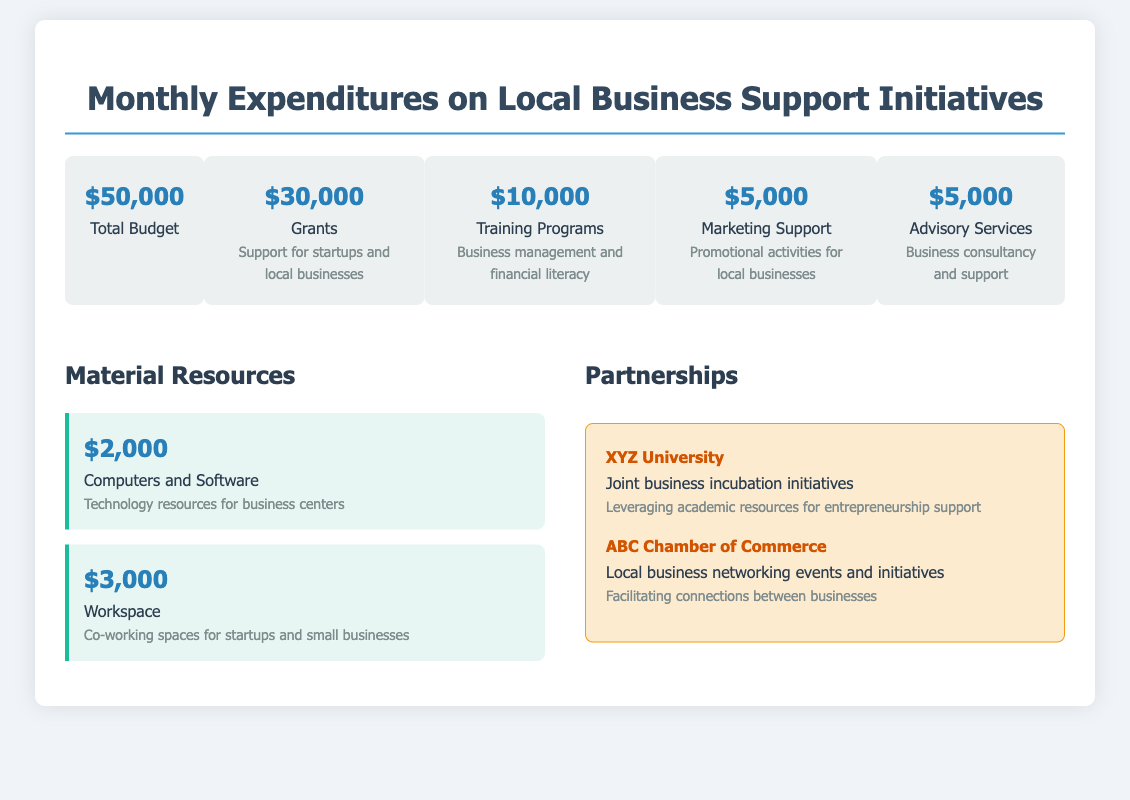What is the total budget? The total budget is displayed prominently in the document as $50,000.
Answer: $50,000 How much is allocated for grants? The document specifies that $30,000 is allocated for grants supporting startups and local businesses.
Answer: $30,000 What is the amount for training programs? The specific allocation for training programs is mentioned in the budget as $10,000.
Answer: $10,000 What is the description of the marketing support budget item? The description for the marketing support indicates it covers promotional activities for local businesses.
Answer: Promotional activities for local businesses How many partnerships are listed in the document? There are two partnerships mentioned: XYZ University and ABC Chamber of Commerce.
Answer: 2 What is the total amount allocated for advisory services? The document states that $5,000 is allocated for advisory services.
Answer: $5,000 What resources are provided for workspace? The document outlines that $3,000 is allocated for co-working spaces for startups and small businesses.
Answer: Co-working spaces for startups and small businesses Which university is mentioned in the partnerships section? The partnerships section mentions XYZ University for joint business incubation initiatives.
Answer: XYZ University What type of support is provided by ABC Chamber of Commerce? ABC Chamber of Commerce facilitates local business networking events and initiatives mentioned in the document.
Answer: Local business networking events and initiatives 